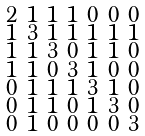<formula> <loc_0><loc_0><loc_500><loc_500>\begin{smallmatrix} 2 & 1 & 1 & 1 & 0 & 0 & 0 \\ 1 & 3 & 1 & 1 & 1 & 1 & 1 \\ 1 & 1 & 3 & 0 & 1 & 1 & 0 \\ 1 & 1 & 0 & 3 & 1 & 0 & 0 \\ 0 & 1 & 1 & 1 & 3 & 1 & 0 \\ 0 & 1 & 1 & 0 & 1 & 3 & 0 \\ 0 & 1 & 0 & 0 & 0 & 0 & 3 \end{smallmatrix}</formula> 